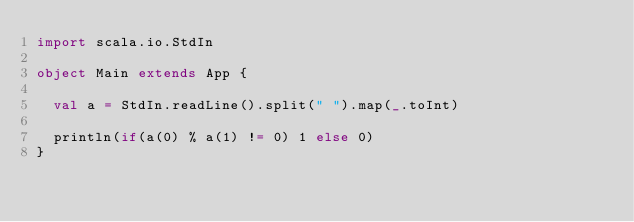<code> <loc_0><loc_0><loc_500><loc_500><_Scala_>import scala.io.StdIn

object Main extends App {

  val a = StdIn.readLine().split(" ").map(_.toInt)

  println(if(a(0) % a(1) != 0) 1 else 0)
}</code> 